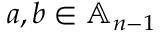Convert formula to latex. <formula><loc_0><loc_0><loc_500><loc_500>a , b \in \mathbb { A } _ { n - 1 }</formula> 